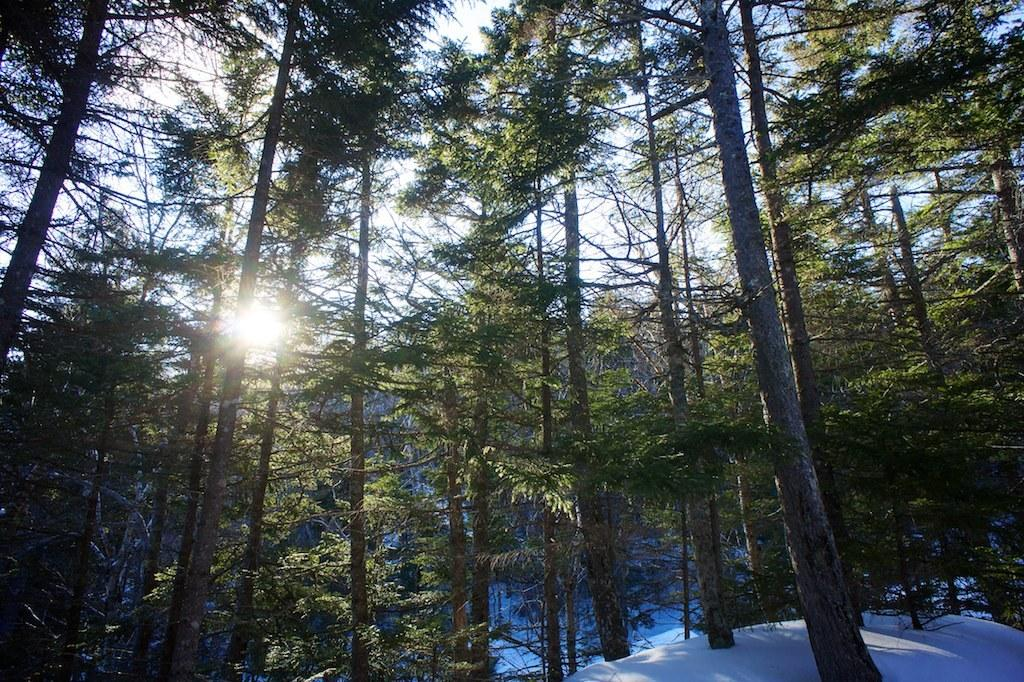What type of vegetation is in the middle of the image? There are tall trees in the middle of the image. What is covering the ground at the bottom of the image? There is snow at the bottom of the image. What is visible at the top of the image? The sky and a sun are visible at the top of the image. Where is the bucket located in the image? There is no bucket present in the image. What type of horn can be seen in the image? There is no horn present in the image. 